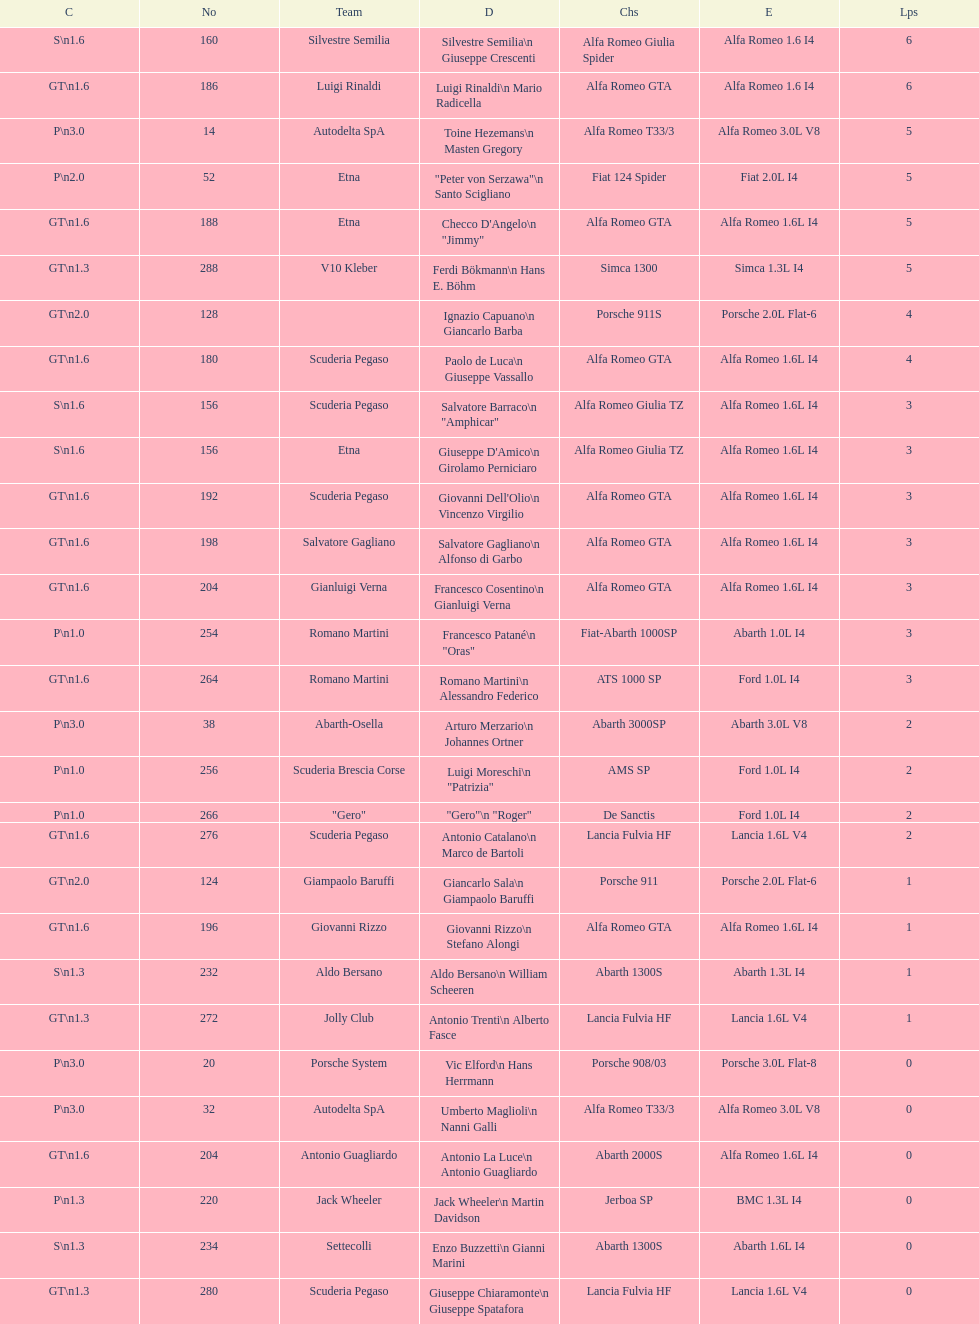His nickname is "jimmy," but what is his full name? Checco D'Angelo. 